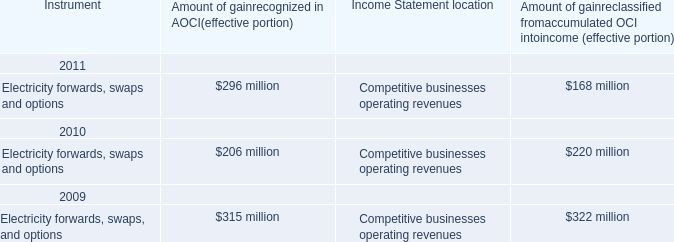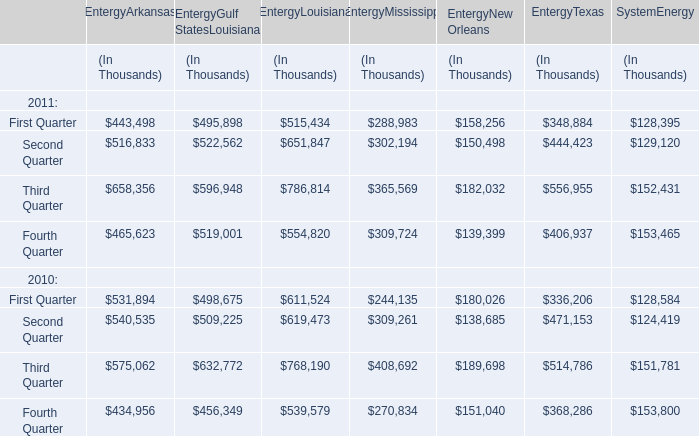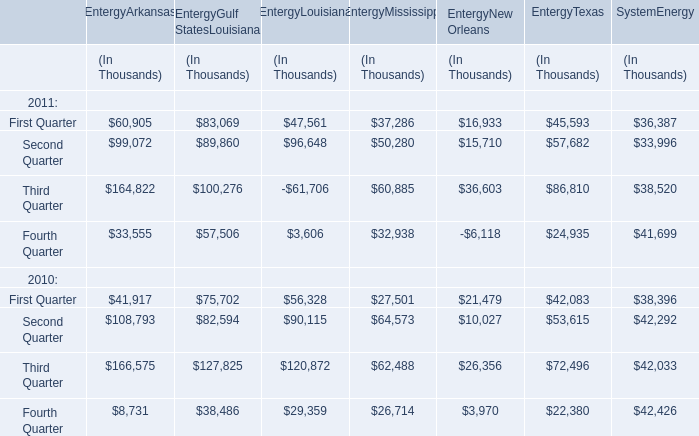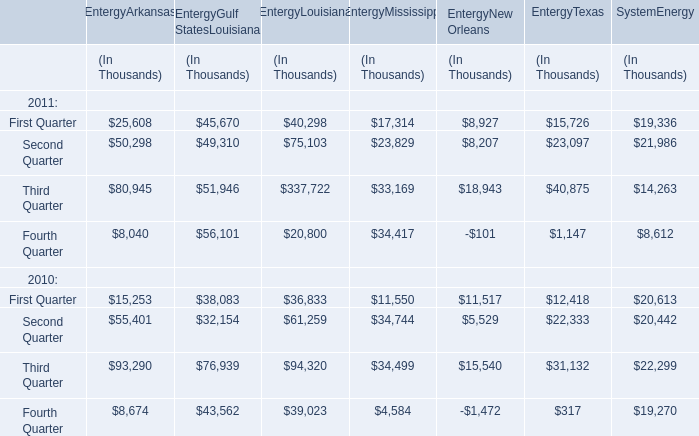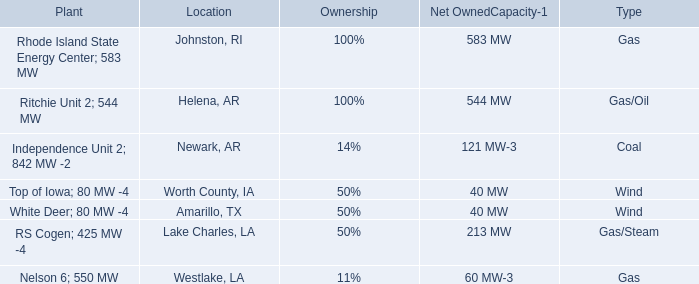In which years is First Quarter greater than Fourth Quarter (for EntergyArkansas? 
Answer: 2010. 